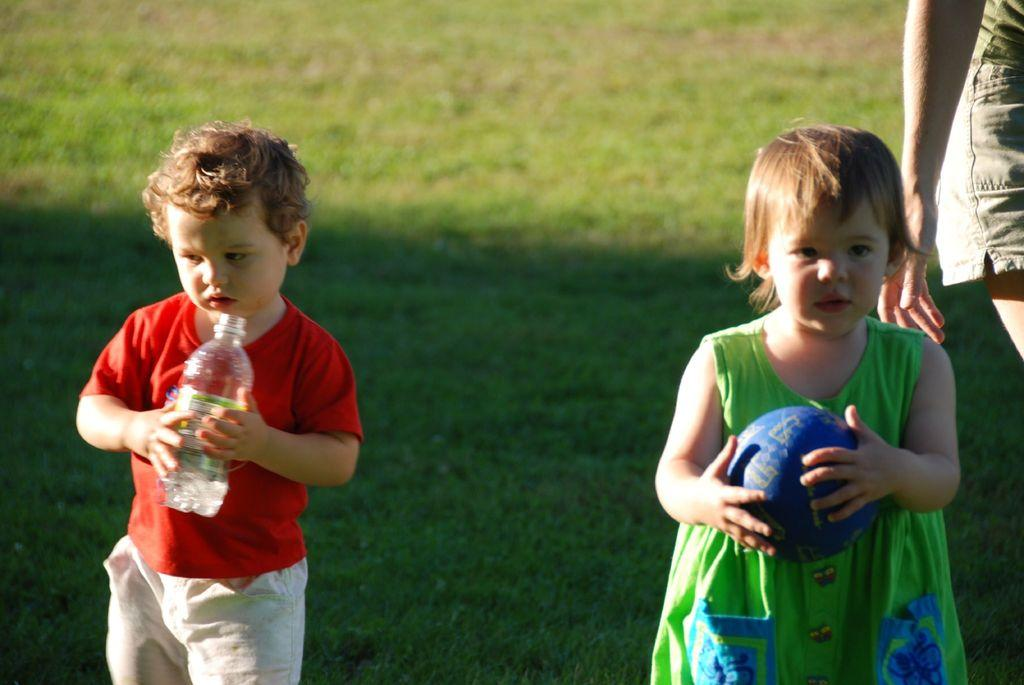What is the boy in the image holding? The boy is holding a bottle in his hand. What is the girl in the image holding? The girl is holding a ball in her hand. Can you describe the woman in the image? There is a woman in the image, but no specific details are provided about her. What can be seen in the background of the image? Grass is visible in the background of the image. What type of treatment is the sponge receiving in the image? There is no sponge present in the image, so it is not possible to answer that question. 